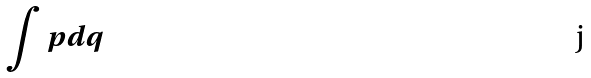<formula> <loc_0><loc_0><loc_500><loc_500>\int p d q</formula> 